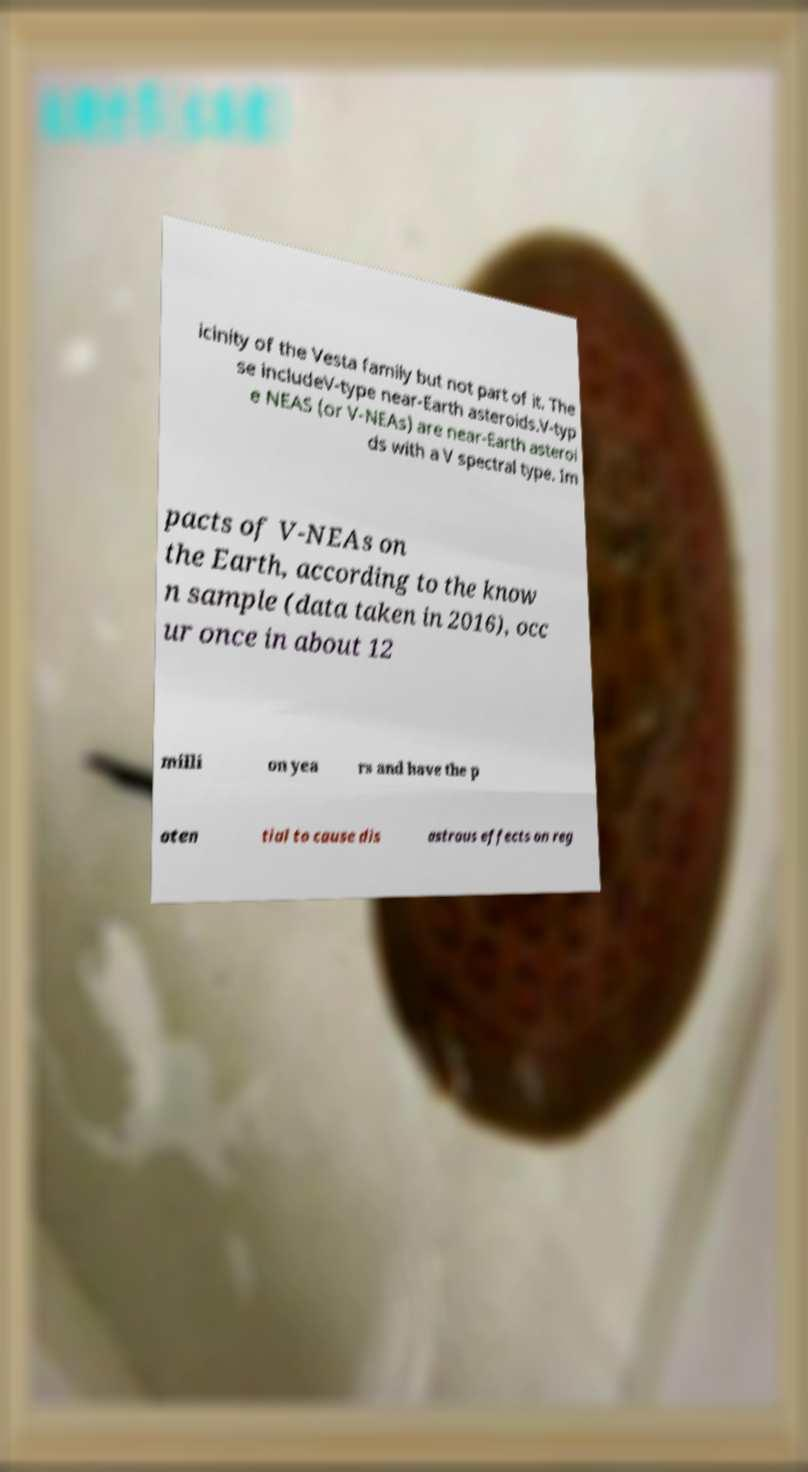I need the written content from this picture converted into text. Can you do that? icinity of the Vesta family but not part of it. The se includeV-type near-Earth asteroids.V-typ e NEAS (or V-NEAs) are near-Earth asteroi ds with a V spectral type. Im pacts of V-NEAs on the Earth, according to the know n sample (data taken in 2016), occ ur once in about 12 milli on yea rs and have the p oten tial to cause dis astrous effects on reg 